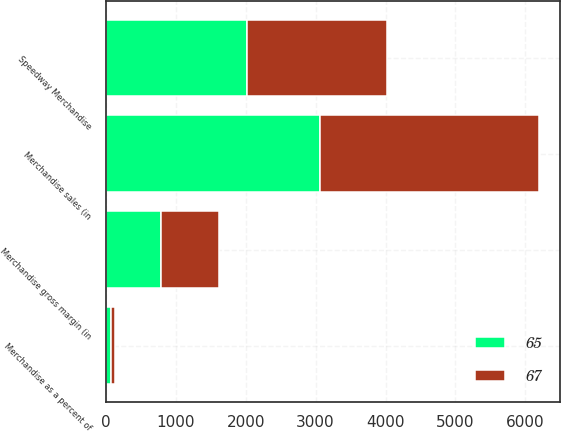Convert chart to OTSL. <chart><loc_0><loc_0><loc_500><loc_500><stacked_bar_chart><ecel><fcel>Speedway Merchandise<fcel>Merchandise sales (in<fcel>Merchandise gross margin (in<fcel>Merchandise as a percent of<nl><fcel>67<fcel>2013<fcel>3135<fcel>825<fcel>65<nl><fcel>65<fcel>2012<fcel>3058<fcel>795<fcel>67<nl></chart> 